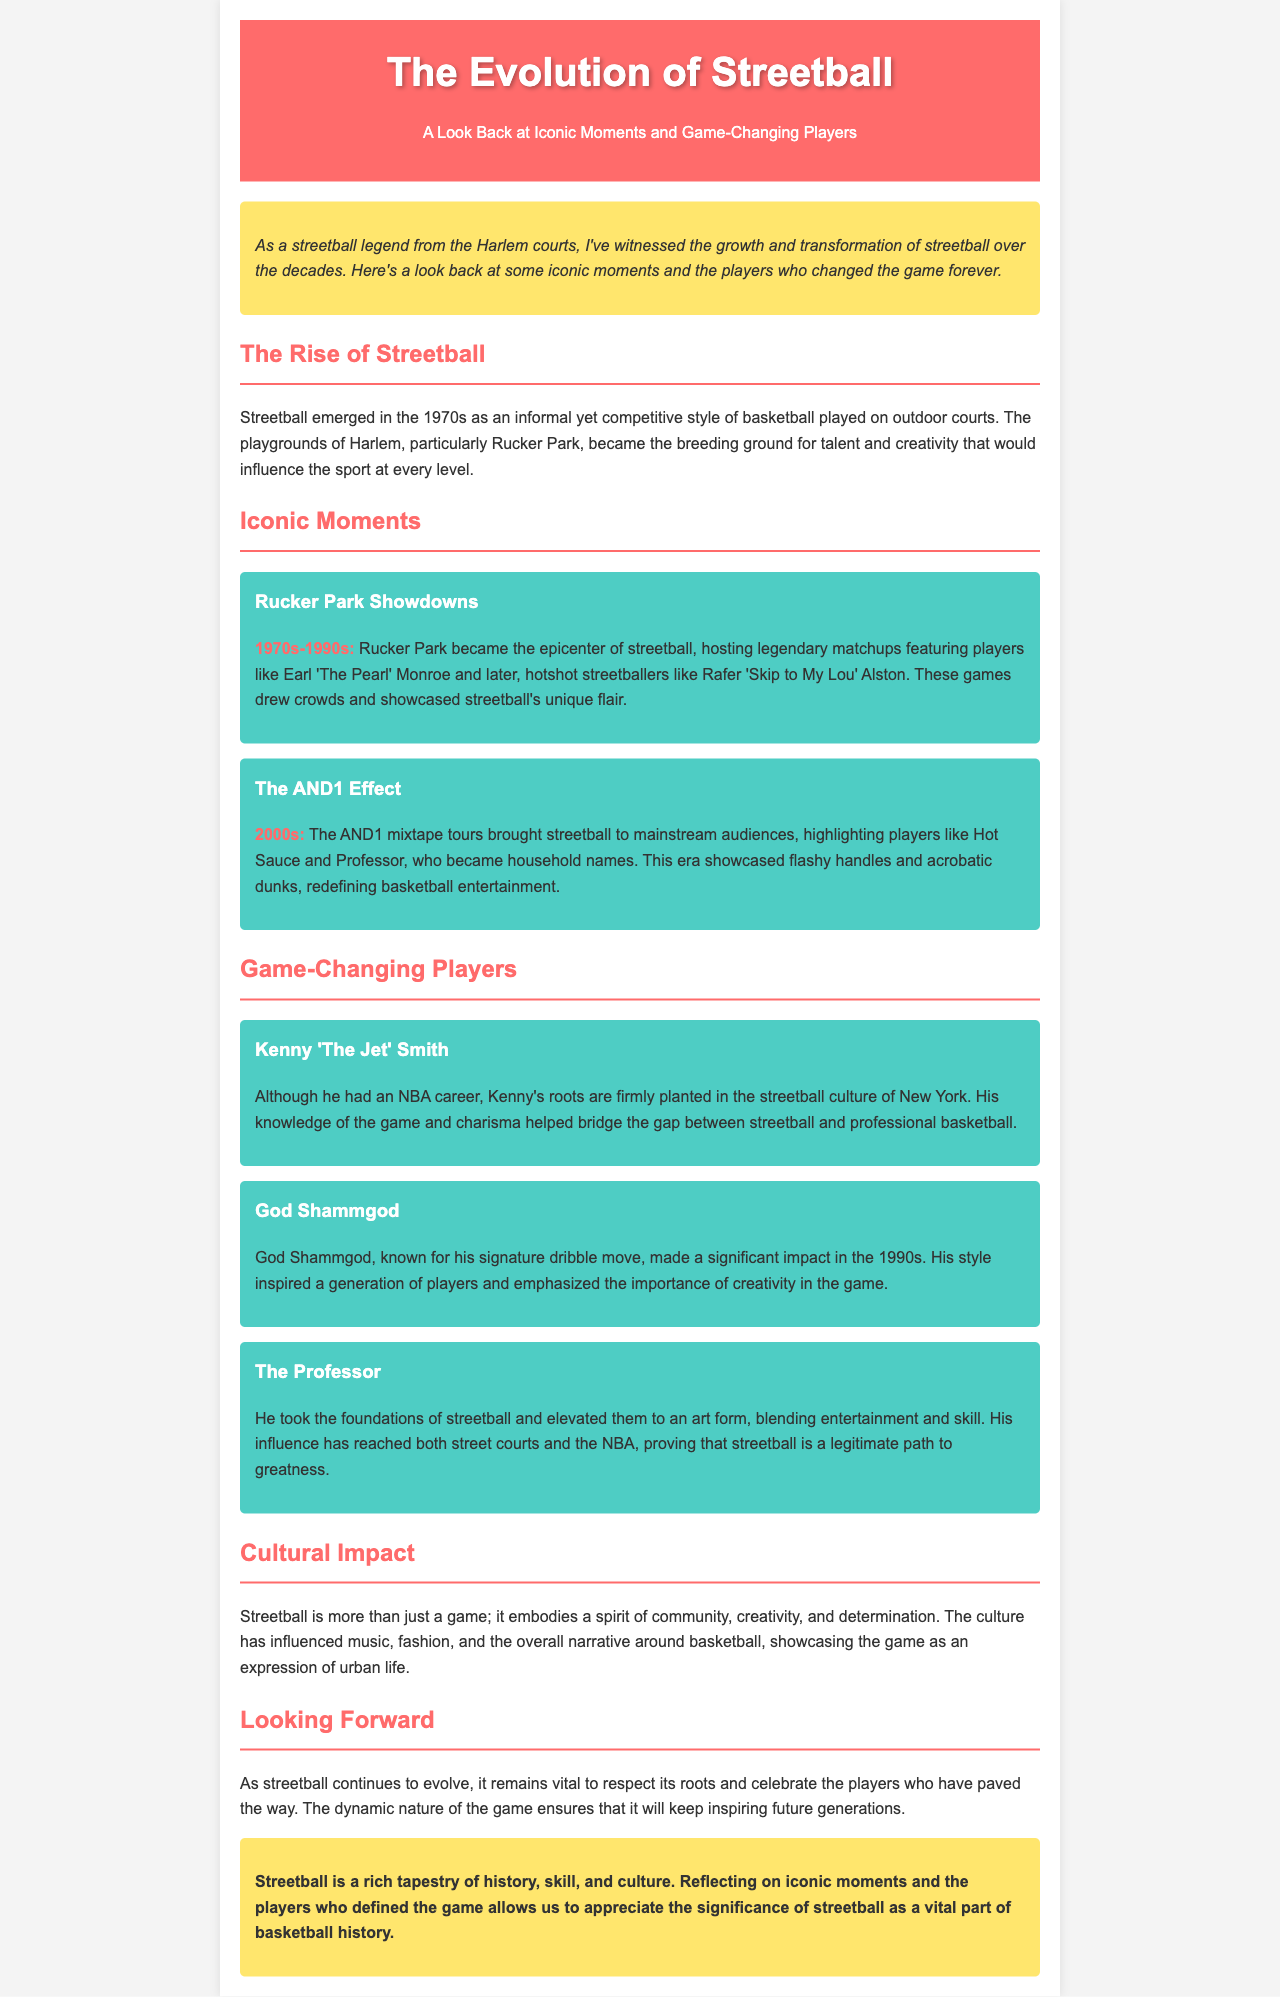What decade did streetball emerge? Streetball emerged in the 1970s, according to the document's content.
Answer: 1970s What was the name of the iconic playground in Harlem? The document mentions Rucker Park as the iconic playground of streetball in Harlem.
Answer: Rucker Park Who is known for the signature dribble move? God Shammgod is highlighted for his signature dribble move in the text.
Answer: God Shammgod Which player is associated with the AND1 mixtape tours? The document identifies players like Hot Sauce and Professor as part of the AND1 effect.
Answer: Hot Sauce What does streetball emphasize in its culture? The document states that streetball embodies a spirit of community, creativity, and determination.
Answer: Community, creativity, and determination Who helped bridge the gap between streetball and professional basketball? Kenny 'The Jet' Smith is mentioned as having helped bridge this gap in the document.
Answer: Kenny 'The Jet' Smith What has streetball influenced besides basketball? The document notes that streetball has influenced music and fashion, among other areas.
Answer: Music and fashion When did the AND1 effect take place? The text indicates that the AND1 effect occurred in the 2000s.
Answer: 2000s 